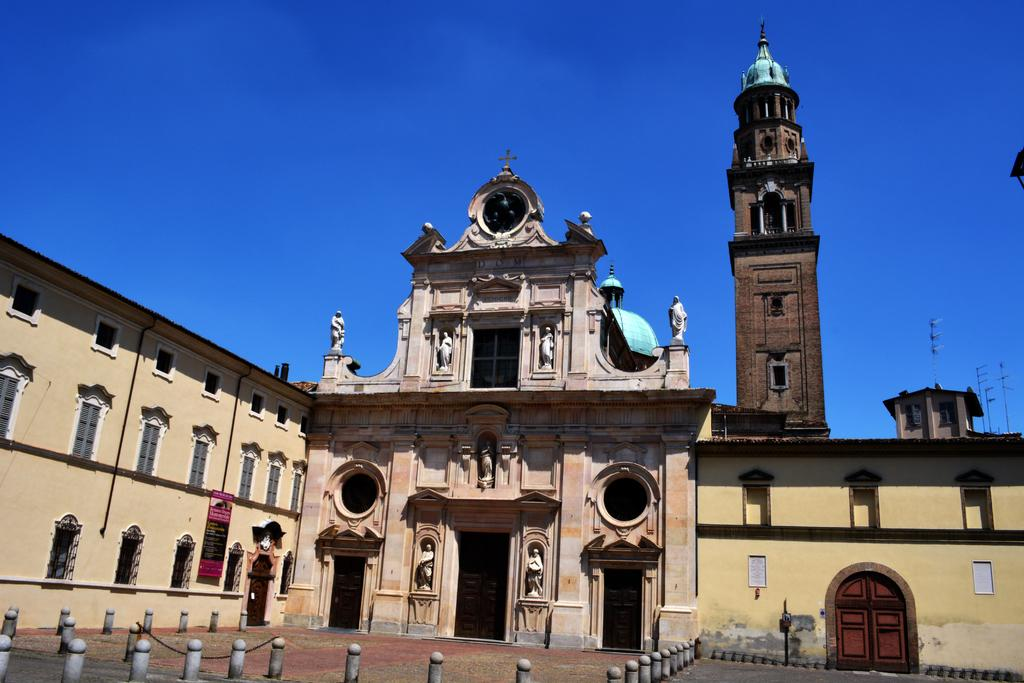What type of building is in the image? There is a church in the image. What other structure can be seen in the image? There is a tower in the image. What objects are present in the image that might be used for support or guidance? There are poles and barrier rods on a path in the image. What type of signage is present in the image? There is a banner with text in the image. What is visible in the background of the image? The sky is visible in the background of the image. What type of crack can be seen forming on the church's roof in the image? There is no crack visible on the church's roof in the image. What type of belief is represented by the banner in the image? The image does not provide enough information to determine the belief represented by the banner. 